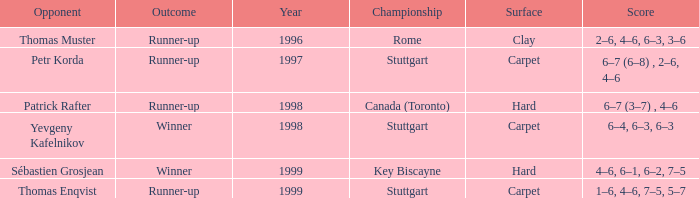What was the outcome before 1997? Runner-up. 